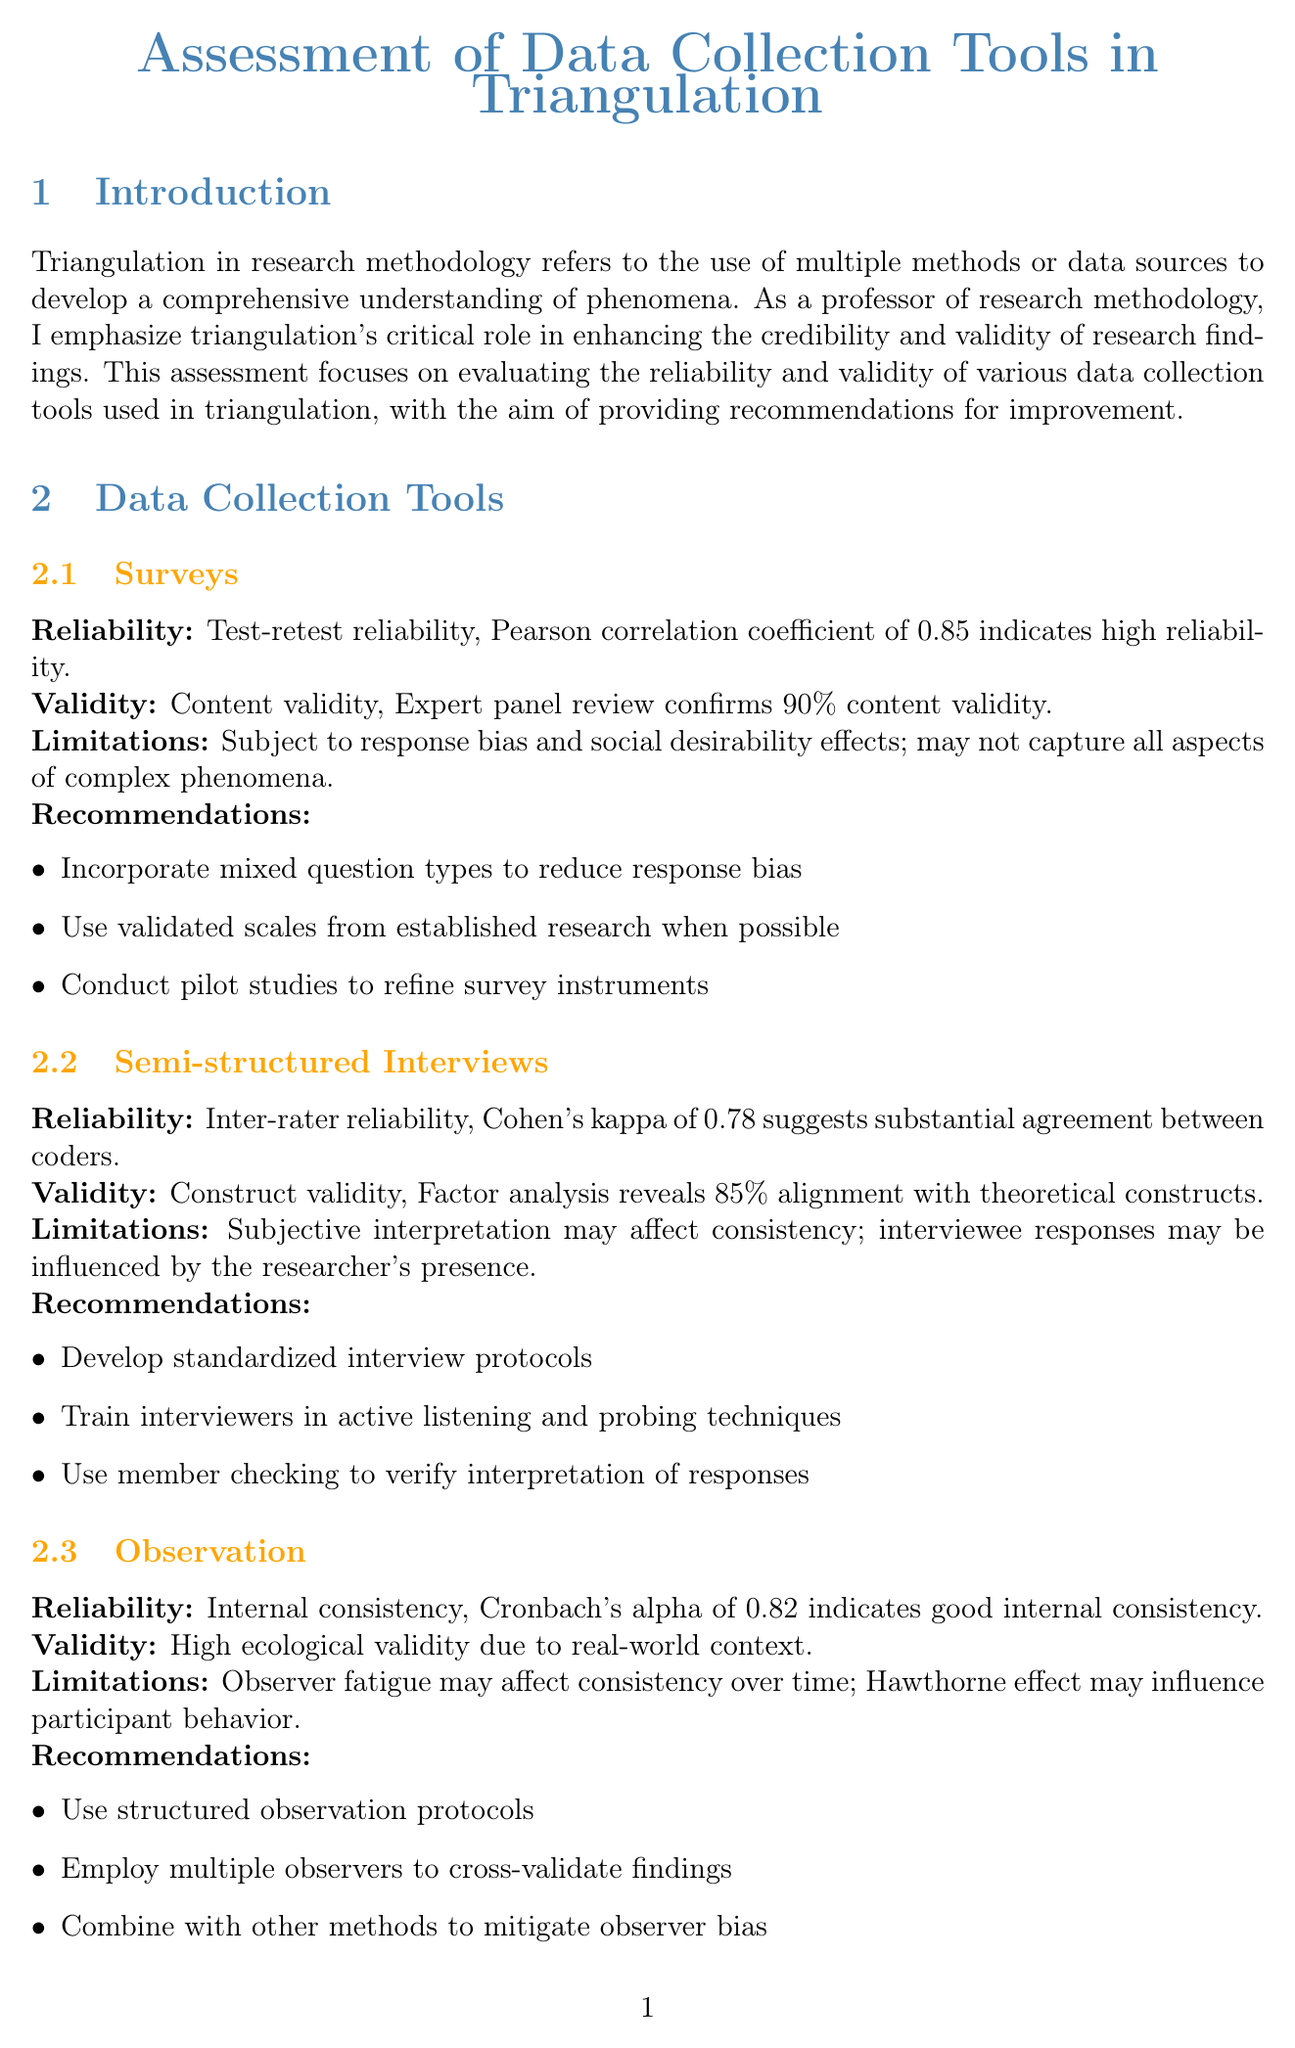What is the Pearson correlation coefficient for surveys? The document states a Pearson correlation coefficient of 0.85 indicates high reliability in surveys.
Answer: 0.85 What percentage of content validity was confirmed by the expert panel for surveys? The expert panel review confirms 90 percent content validity for surveys.
Answer: 90% Who conducted the research on online learning platforms? The document specifies that the research on online learning platforms was conducted by Dr. Emily Chen from Stanford University.
Answer: Dr. Emily Chen What is one improvement recommendation for semi-structured interviews? The document lists several recommendations, one being to develop standardized interview protocols for semi-structured interviews.
Answer: Develop standardized interview protocols What is the Cohen's kappa value indicating for semi-structured interviews? Cohen's kappa of 0.78 suggests substantial agreement between coders for semi-structured interviews.
Answer: 0.78 What type of triangulation was used in the study assessing corporate sustainability practices? The document states that data source triangulation was used in the study assessing corporate sustainability practices.
Answer: Data source triangulation What is the internal consistency value (Cronbach's alpha) for observation? The document indicates that Cronbach's alpha of 0.82 indicates good internal consistency for observation.
Answer: 0.82 What is the main purpose of triangulation in research methodology? The introduction emphasizes that triangulation refers to the use of multiple methods or data sources to develop a comprehensive understanding of phenomena.
Answer: Comprehensive understanding What was the key finding regarding stakeholder interviews in the corporate sustainability study? The document notes that stakeholder interviews provided context for discrepancies in the corporate sustainability practices study.
Answer: Context for discrepancies 